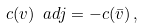<formula> <loc_0><loc_0><loc_500><loc_500>c ( v ) \ a d j = - c ( \bar { v } ) \, ,</formula> 